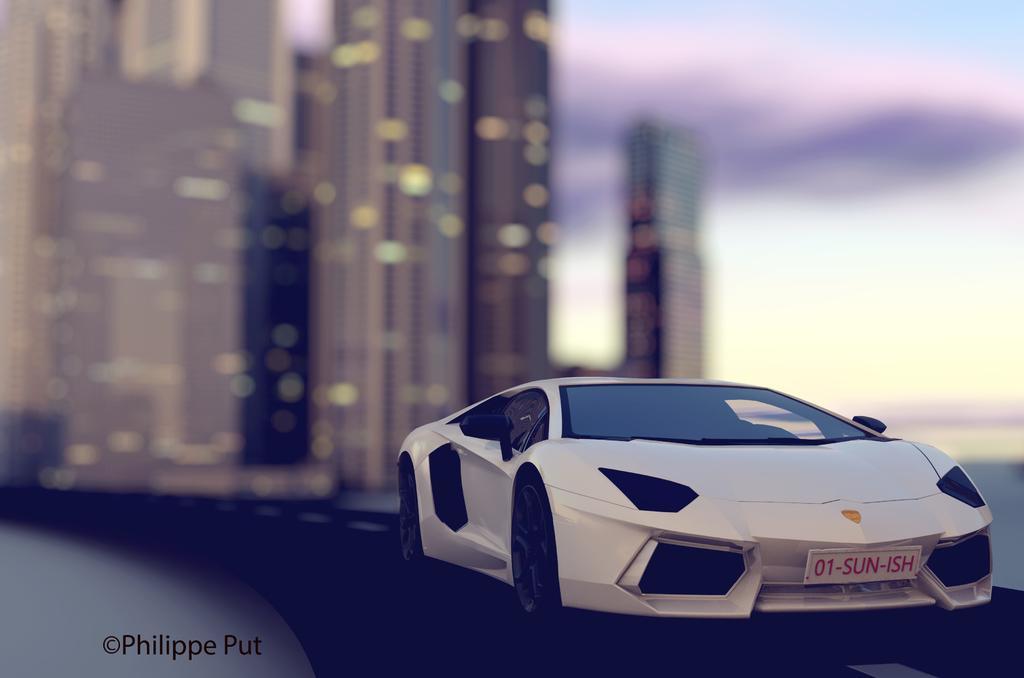How would you summarize this image in a sentence or two? It is an edited image, there is a toy car in the foreground and the background of the car is blur, there is some name at the bottom left corner of the image. 